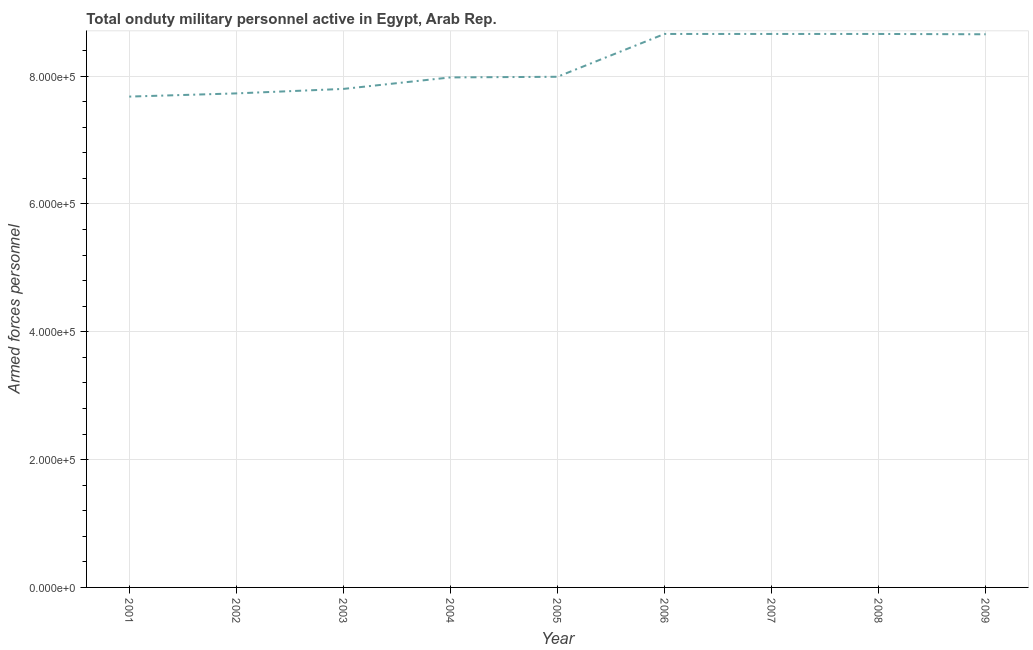What is the number of armed forces personnel in 2002?
Provide a short and direct response. 7.73e+05. Across all years, what is the maximum number of armed forces personnel?
Your response must be concise. 8.66e+05. Across all years, what is the minimum number of armed forces personnel?
Give a very brief answer. 7.68e+05. In which year was the number of armed forces personnel minimum?
Make the answer very short. 2001. What is the sum of the number of armed forces personnel?
Make the answer very short. 7.38e+06. What is the difference between the number of armed forces personnel in 2003 and 2006?
Provide a short and direct response. -8.60e+04. What is the average number of armed forces personnel per year?
Your answer should be very brief. 8.20e+05. What is the median number of armed forces personnel?
Your answer should be compact. 7.99e+05. In how many years, is the number of armed forces personnel greater than 360000 ?
Your answer should be very brief. 9. What is the ratio of the number of armed forces personnel in 2001 to that in 2002?
Offer a terse response. 0.99. Is the number of armed forces personnel in 2001 less than that in 2007?
Provide a short and direct response. Yes. What is the difference between the highest and the second highest number of armed forces personnel?
Make the answer very short. 0. Is the sum of the number of armed forces personnel in 2007 and 2008 greater than the maximum number of armed forces personnel across all years?
Make the answer very short. Yes. What is the difference between the highest and the lowest number of armed forces personnel?
Your answer should be very brief. 9.80e+04. In how many years, is the number of armed forces personnel greater than the average number of armed forces personnel taken over all years?
Offer a very short reply. 4. What is the difference between two consecutive major ticks on the Y-axis?
Provide a succinct answer. 2.00e+05. Are the values on the major ticks of Y-axis written in scientific E-notation?
Give a very brief answer. Yes. Does the graph contain any zero values?
Offer a terse response. No. What is the title of the graph?
Provide a succinct answer. Total onduty military personnel active in Egypt, Arab Rep. What is the label or title of the Y-axis?
Provide a short and direct response. Armed forces personnel. What is the Armed forces personnel in 2001?
Your response must be concise. 7.68e+05. What is the Armed forces personnel in 2002?
Your answer should be compact. 7.73e+05. What is the Armed forces personnel of 2003?
Give a very brief answer. 7.80e+05. What is the Armed forces personnel in 2004?
Make the answer very short. 7.98e+05. What is the Armed forces personnel of 2005?
Your response must be concise. 7.99e+05. What is the Armed forces personnel in 2006?
Keep it short and to the point. 8.66e+05. What is the Armed forces personnel in 2007?
Ensure brevity in your answer.  8.66e+05. What is the Armed forces personnel in 2008?
Ensure brevity in your answer.  8.66e+05. What is the Armed forces personnel in 2009?
Your answer should be compact. 8.66e+05. What is the difference between the Armed forces personnel in 2001 and 2002?
Ensure brevity in your answer.  -5000. What is the difference between the Armed forces personnel in 2001 and 2003?
Your answer should be very brief. -1.20e+04. What is the difference between the Armed forces personnel in 2001 and 2005?
Your answer should be compact. -3.10e+04. What is the difference between the Armed forces personnel in 2001 and 2006?
Offer a terse response. -9.80e+04. What is the difference between the Armed forces personnel in 2001 and 2007?
Your answer should be compact. -9.80e+04. What is the difference between the Armed forces personnel in 2001 and 2008?
Your response must be concise. -9.80e+04. What is the difference between the Armed forces personnel in 2001 and 2009?
Provide a succinct answer. -9.75e+04. What is the difference between the Armed forces personnel in 2002 and 2003?
Ensure brevity in your answer.  -7000. What is the difference between the Armed forces personnel in 2002 and 2004?
Ensure brevity in your answer.  -2.50e+04. What is the difference between the Armed forces personnel in 2002 and 2005?
Ensure brevity in your answer.  -2.60e+04. What is the difference between the Armed forces personnel in 2002 and 2006?
Offer a terse response. -9.30e+04. What is the difference between the Armed forces personnel in 2002 and 2007?
Provide a short and direct response. -9.30e+04. What is the difference between the Armed forces personnel in 2002 and 2008?
Keep it short and to the point. -9.30e+04. What is the difference between the Armed forces personnel in 2002 and 2009?
Give a very brief answer. -9.25e+04. What is the difference between the Armed forces personnel in 2003 and 2004?
Ensure brevity in your answer.  -1.80e+04. What is the difference between the Armed forces personnel in 2003 and 2005?
Give a very brief answer. -1.90e+04. What is the difference between the Armed forces personnel in 2003 and 2006?
Provide a succinct answer. -8.60e+04. What is the difference between the Armed forces personnel in 2003 and 2007?
Offer a terse response. -8.60e+04. What is the difference between the Armed forces personnel in 2003 and 2008?
Give a very brief answer. -8.60e+04. What is the difference between the Armed forces personnel in 2003 and 2009?
Your response must be concise. -8.55e+04. What is the difference between the Armed forces personnel in 2004 and 2005?
Make the answer very short. -1000. What is the difference between the Armed forces personnel in 2004 and 2006?
Ensure brevity in your answer.  -6.80e+04. What is the difference between the Armed forces personnel in 2004 and 2007?
Ensure brevity in your answer.  -6.80e+04. What is the difference between the Armed forces personnel in 2004 and 2008?
Your answer should be compact. -6.80e+04. What is the difference between the Armed forces personnel in 2004 and 2009?
Make the answer very short. -6.75e+04. What is the difference between the Armed forces personnel in 2005 and 2006?
Make the answer very short. -6.70e+04. What is the difference between the Armed forces personnel in 2005 and 2007?
Your answer should be compact. -6.70e+04. What is the difference between the Armed forces personnel in 2005 and 2008?
Make the answer very short. -6.70e+04. What is the difference between the Armed forces personnel in 2005 and 2009?
Keep it short and to the point. -6.65e+04. What is the difference between the Armed forces personnel in 2006 and 2007?
Ensure brevity in your answer.  0. What is the difference between the Armed forces personnel in 2006 and 2009?
Provide a short and direct response. 500. What is the difference between the Armed forces personnel in 2008 and 2009?
Ensure brevity in your answer.  500. What is the ratio of the Armed forces personnel in 2001 to that in 2002?
Provide a short and direct response. 0.99. What is the ratio of the Armed forces personnel in 2001 to that in 2003?
Your response must be concise. 0.98. What is the ratio of the Armed forces personnel in 2001 to that in 2004?
Make the answer very short. 0.96. What is the ratio of the Armed forces personnel in 2001 to that in 2006?
Your response must be concise. 0.89. What is the ratio of the Armed forces personnel in 2001 to that in 2007?
Provide a short and direct response. 0.89. What is the ratio of the Armed forces personnel in 2001 to that in 2008?
Provide a succinct answer. 0.89. What is the ratio of the Armed forces personnel in 2001 to that in 2009?
Give a very brief answer. 0.89. What is the ratio of the Armed forces personnel in 2002 to that in 2003?
Offer a terse response. 0.99. What is the ratio of the Armed forces personnel in 2002 to that in 2004?
Your response must be concise. 0.97. What is the ratio of the Armed forces personnel in 2002 to that in 2006?
Make the answer very short. 0.89. What is the ratio of the Armed forces personnel in 2002 to that in 2007?
Offer a very short reply. 0.89. What is the ratio of the Armed forces personnel in 2002 to that in 2008?
Provide a succinct answer. 0.89. What is the ratio of the Armed forces personnel in 2002 to that in 2009?
Your response must be concise. 0.89. What is the ratio of the Armed forces personnel in 2003 to that in 2005?
Your response must be concise. 0.98. What is the ratio of the Armed forces personnel in 2003 to that in 2006?
Give a very brief answer. 0.9. What is the ratio of the Armed forces personnel in 2003 to that in 2007?
Your response must be concise. 0.9. What is the ratio of the Armed forces personnel in 2003 to that in 2008?
Give a very brief answer. 0.9. What is the ratio of the Armed forces personnel in 2003 to that in 2009?
Offer a terse response. 0.9. What is the ratio of the Armed forces personnel in 2004 to that in 2005?
Your answer should be very brief. 1. What is the ratio of the Armed forces personnel in 2004 to that in 2006?
Offer a terse response. 0.92. What is the ratio of the Armed forces personnel in 2004 to that in 2007?
Offer a very short reply. 0.92. What is the ratio of the Armed forces personnel in 2004 to that in 2008?
Your answer should be very brief. 0.92. What is the ratio of the Armed forces personnel in 2004 to that in 2009?
Ensure brevity in your answer.  0.92. What is the ratio of the Armed forces personnel in 2005 to that in 2006?
Offer a terse response. 0.92. What is the ratio of the Armed forces personnel in 2005 to that in 2007?
Offer a terse response. 0.92. What is the ratio of the Armed forces personnel in 2005 to that in 2008?
Keep it short and to the point. 0.92. What is the ratio of the Armed forces personnel in 2005 to that in 2009?
Provide a succinct answer. 0.92. What is the ratio of the Armed forces personnel in 2006 to that in 2007?
Provide a short and direct response. 1. What is the ratio of the Armed forces personnel in 2006 to that in 2009?
Ensure brevity in your answer.  1. What is the ratio of the Armed forces personnel in 2007 to that in 2009?
Provide a succinct answer. 1. What is the ratio of the Armed forces personnel in 2008 to that in 2009?
Make the answer very short. 1. 